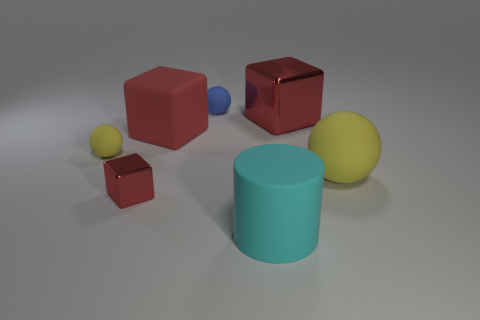How many red cubes must be subtracted to get 1 red cubes? 2 Add 3 brown rubber cylinders. How many objects exist? 10 Subtract all cubes. How many objects are left? 4 Add 3 large metal cubes. How many large metal cubes are left? 4 Add 1 yellow rubber things. How many yellow rubber things exist? 3 Subtract 0 yellow cylinders. How many objects are left? 7 Subtract all small blue matte objects. Subtract all green metal cubes. How many objects are left? 6 